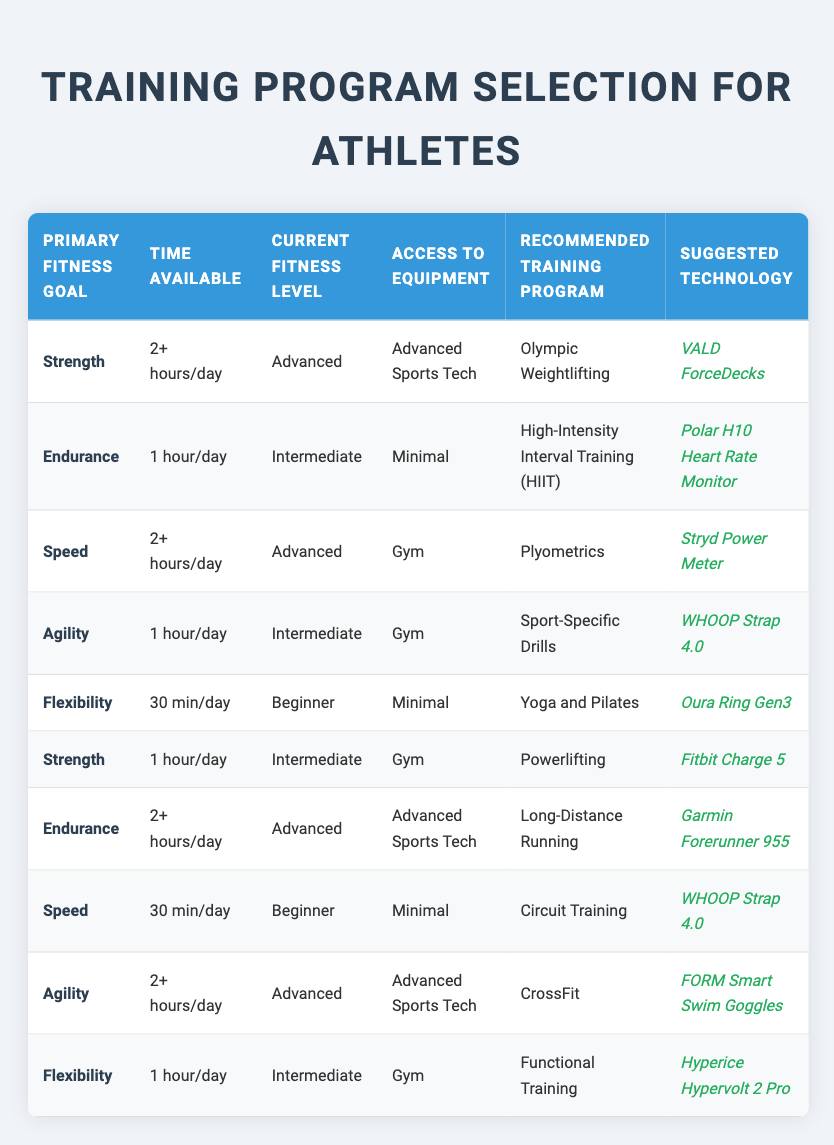What training program is recommended for someone with an endurance goal, who has 1 hour a day and is at an intermediate level with minimal equipment? To find the answer, look at the conditions for "Endurance" in the "Primary Fitness Goal" column. Then check "1 hour/day" in the "Time Available" column, "Intermediate" in the "Current Fitness Level" column, and "Minimal" in the "Access to Equipment" column. This matches with the row that recommends "High-Intensity Interval Training (HIIT)."
Answer: High-Intensity Interval Training (HIIT) Is Olympic Weightlifting suggested for individuals who have more than 2 hours available per day and are advanced in strength with advanced sports technology? Check if there is a row for the combination of "Strength," "2+ hours/day," "Advanced," and "Advanced Sports Tech." Yes, the recommended program is Olympic Weightlifting, confirming it as a valid suggestion.
Answer: Yes What technology is suggested for someone whose primary fitness goal is agility, has 2 or more hours per day to train, is at an advanced level, and has access to advanced sports technology? Locate the conditions for "Agility" in the table and see if there's a match for "2+ hours/day," "Advanced" fitness level, and "Advanced Sports Tech." The suggestion is "CrossFit" and the corresponding technology is "FORM Smart Swim Goggles."
Answer: FORM Smart Swim Goggles How many recommended training programs focus on flexibility? Identify rows in the table where "Flexibility" is the primary fitness goal. There are two entries with "Yoga and Pilates" and "Functional Training" as recommended programs, so count these entries.
Answer: 2 Is there any training program recommended for someone with a primary goal of speed, who is a beginner and has minimal access to equipment? Check for the condition entries where "Speed" is the primary goal. Indeed, there is a row that encompasses "30 min/day," "Beginner," and "Minimal" access, which suggests "Circuit Training."
Answer: Yes What is the suggested technology for someone with an endurance goal having access to advanced sports tech and 2 or more hours to train at an advanced level? Search for "Endurance" in the primary goal, then check for the conditions that match "2+ hours/day" and "Advanced" level with "Advanced Sports Tech." The row shows that the technology suggested is "Garmin Forerunner 955."
Answer: Garmin Forerunner 955 Which training program is not recommended for beginners? Review all training programs and look for the rows with the "Beginner" fitness level. The "Olympic Weightlifting" and "Plyometrics" programs do not appear under the beginner category, hence they are not recommended for beginners.
Answer: Olympic Weightlifting, Plyometrics What is the recommended training program for a strength goal with 1 hour available per day at an intermediate level with gym access? Find the row for "Strength" listed as the primary goal, "1 hour/day" for time available, "Intermediate" for fitness level, and "Gym" for access. This aligns with "Powerlifting" as the recommended training program.
Answer: Powerlifting 